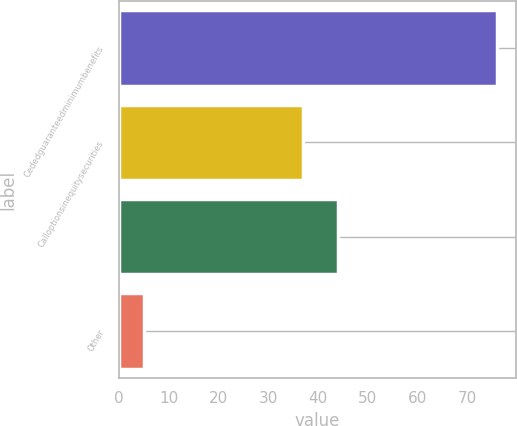Convert chart. <chart><loc_0><loc_0><loc_500><loc_500><bar_chart><fcel>Cededguaranteedminimumbenefits<fcel>Calloptionsinequitysecurities<fcel>Unnamed: 2<fcel>Other<nl><fcel>76<fcel>37<fcel>44.1<fcel>5<nl></chart> 